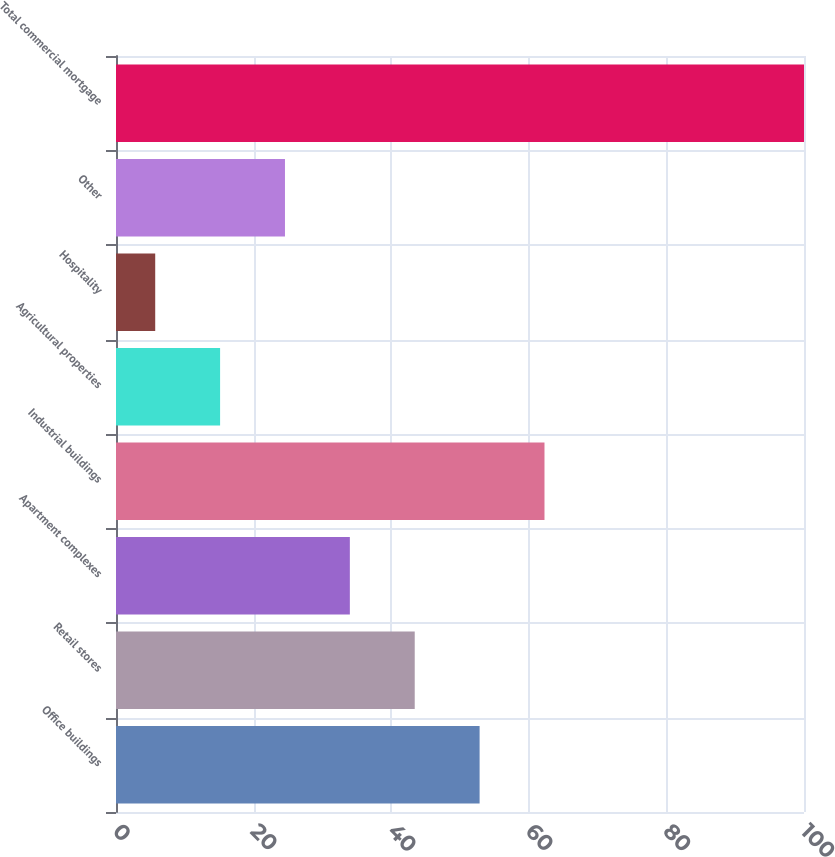Convert chart. <chart><loc_0><loc_0><loc_500><loc_500><bar_chart><fcel>Office buildings<fcel>Retail stores<fcel>Apartment complexes<fcel>Industrial buildings<fcel>Agricultural properties<fcel>Hospitality<fcel>Other<fcel>Total commercial mortgage<nl><fcel>52.85<fcel>43.42<fcel>33.99<fcel>62.28<fcel>15.13<fcel>5.7<fcel>24.56<fcel>100<nl></chart> 